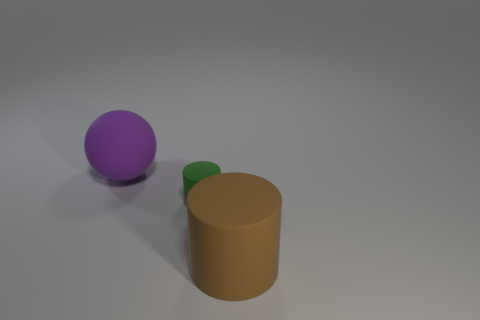Subtract 2 cylinders. How many cylinders are left? 0 Subtract all cylinders. How many objects are left? 1 Subtract all blue balls. Subtract all blue cylinders. How many balls are left? 1 Subtract all yellow cubes. How many brown cylinders are left? 1 Subtract all purple spheres. Subtract all small rubber objects. How many objects are left? 1 Add 2 brown matte cylinders. How many brown matte cylinders are left? 3 Add 3 big brown things. How many big brown things exist? 4 Add 1 large yellow metallic cylinders. How many objects exist? 4 Subtract all brown cylinders. How many cylinders are left? 1 Subtract 0 purple cubes. How many objects are left? 3 